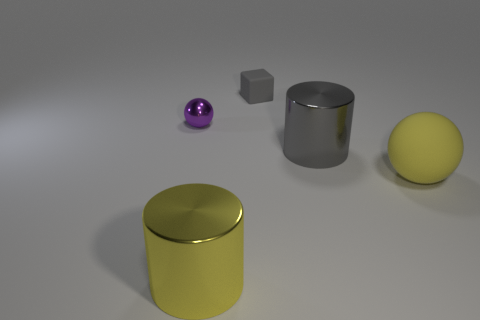Add 1 large gray cylinders. How many objects exist? 6 Subtract all balls. How many objects are left? 3 Add 4 big spheres. How many big spheres are left? 5 Add 1 large yellow rubber balls. How many large yellow rubber balls exist? 2 Subtract 0 blue cubes. How many objects are left? 5 Subtract all purple rubber cylinders. Subtract all matte objects. How many objects are left? 3 